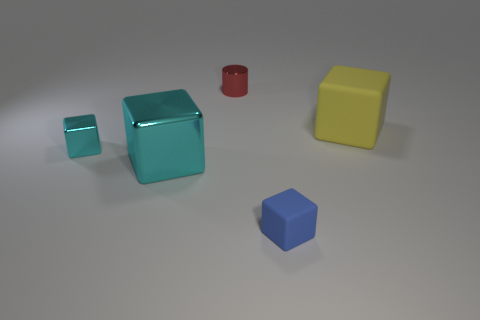Add 1 blue objects. How many objects exist? 6 Subtract all cubes. How many objects are left? 1 Add 1 purple matte spheres. How many purple matte spheres exist? 1 Subtract 1 cyan blocks. How many objects are left? 4 Subtract all tiny blue shiny balls. Subtract all small things. How many objects are left? 2 Add 4 cyan shiny blocks. How many cyan shiny blocks are left? 6 